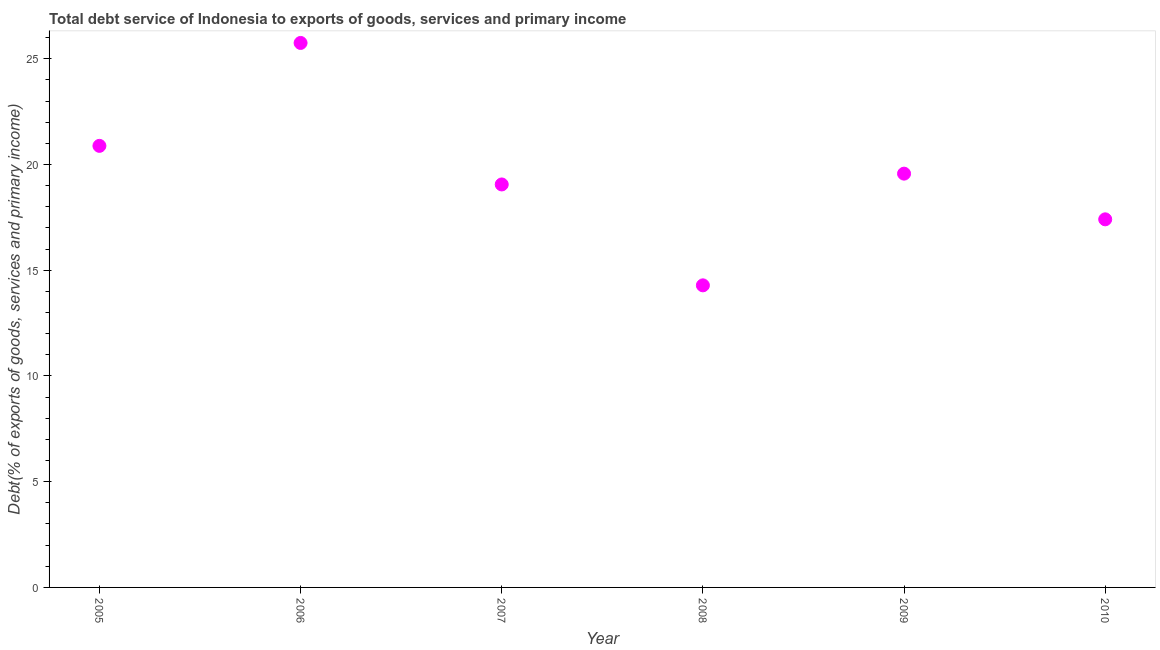What is the total debt service in 2010?
Offer a very short reply. 17.41. Across all years, what is the maximum total debt service?
Your response must be concise. 25.75. Across all years, what is the minimum total debt service?
Your answer should be compact. 14.29. What is the sum of the total debt service?
Your answer should be compact. 116.94. What is the difference between the total debt service in 2006 and 2009?
Offer a very short reply. 6.18. What is the average total debt service per year?
Make the answer very short. 19.49. What is the median total debt service?
Ensure brevity in your answer.  19.31. What is the ratio of the total debt service in 2005 to that in 2009?
Your answer should be very brief. 1.07. Is the total debt service in 2007 less than that in 2008?
Provide a succinct answer. No. What is the difference between the highest and the second highest total debt service?
Keep it short and to the point. 4.87. What is the difference between the highest and the lowest total debt service?
Offer a terse response. 11.46. Does the total debt service monotonically increase over the years?
Offer a very short reply. No. How many years are there in the graph?
Your answer should be compact. 6. Are the values on the major ticks of Y-axis written in scientific E-notation?
Offer a terse response. No. What is the title of the graph?
Make the answer very short. Total debt service of Indonesia to exports of goods, services and primary income. What is the label or title of the X-axis?
Offer a very short reply. Year. What is the label or title of the Y-axis?
Your response must be concise. Debt(% of exports of goods, services and primary income). What is the Debt(% of exports of goods, services and primary income) in 2005?
Provide a short and direct response. 20.88. What is the Debt(% of exports of goods, services and primary income) in 2006?
Keep it short and to the point. 25.75. What is the Debt(% of exports of goods, services and primary income) in 2007?
Keep it short and to the point. 19.06. What is the Debt(% of exports of goods, services and primary income) in 2008?
Offer a terse response. 14.29. What is the Debt(% of exports of goods, services and primary income) in 2009?
Your response must be concise. 19.57. What is the Debt(% of exports of goods, services and primary income) in 2010?
Provide a succinct answer. 17.41. What is the difference between the Debt(% of exports of goods, services and primary income) in 2005 and 2006?
Your answer should be compact. -4.87. What is the difference between the Debt(% of exports of goods, services and primary income) in 2005 and 2007?
Offer a terse response. 1.82. What is the difference between the Debt(% of exports of goods, services and primary income) in 2005 and 2008?
Your answer should be very brief. 6.6. What is the difference between the Debt(% of exports of goods, services and primary income) in 2005 and 2009?
Ensure brevity in your answer.  1.31. What is the difference between the Debt(% of exports of goods, services and primary income) in 2005 and 2010?
Give a very brief answer. 3.47. What is the difference between the Debt(% of exports of goods, services and primary income) in 2006 and 2007?
Your response must be concise. 6.69. What is the difference between the Debt(% of exports of goods, services and primary income) in 2006 and 2008?
Offer a terse response. 11.46. What is the difference between the Debt(% of exports of goods, services and primary income) in 2006 and 2009?
Make the answer very short. 6.18. What is the difference between the Debt(% of exports of goods, services and primary income) in 2006 and 2010?
Give a very brief answer. 8.34. What is the difference between the Debt(% of exports of goods, services and primary income) in 2007 and 2008?
Offer a very short reply. 4.77. What is the difference between the Debt(% of exports of goods, services and primary income) in 2007 and 2009?
Offer a terse response. -0.51. What is the difference between the Debt(% of exports of goods, services and primary income) in 2007 and 2010?
Keep it short and to the point. 1.65. What is the difference between the Debt(% of exports of goods, services and primary income) in 2008 and 2009?
Keep it short and to the point. -5.28. What is the difference between the Debt(% of exports of goods, services and primary income) in 2008 and 2010?
Offer a terse response. -3.12. What is the difference between the Debt(% of exports of goods, services and primary income) in 2009 and 2010?
Your answer should be compact. 2.16. What is the ratio of the Debt(% of exports of goods, services and primary income) in 2005 to that in 2006?
Provide a succinct answer. 0.81. What is the ratio of the Debt(% of exports of goods, services and primary income) in 2005 to that in 2007?
Ensure brevity in your answer.  1.1. What is the ratio of the Debt(% of exports of goods, services and primary income) in 2005 to that in 2008?
Your response must be concise. 1.46. What is the ratio of the Debt(% of exports of goods, services and primary income) in 2005 to that in 2009?
Provide a succinct answer. 1.07. What is the ratio of the Debt(% of exports of goods, services and primary income) in 2005 to that in 2010?
Make the answer very short. 1.2. What is the ratio of the Debt(% of exports of goods, services and primary income) in 2006 to that in 2007?
Provide a short and direct response. 1.35. What is the ratio of the Debt(% of exports of goods, services and primary income) in 2006 to that in 2008?
Your answer should be compact. 1.8. What is the ratio of the Debt(% of exports of goods, services and primary income) in 2006 to that in 2009?
Your answer should be very brief. 1.32. What is the ratio of the Debt(% of exports of goods, services and primary income) in 2006 to that in 2010?
Your answer should be compact. 1.48. What is the ratio of the Debt(% of exports of goods, services and primary income) in 2007 to that in 2008?
Offer a terse response. 1.33. What is the ratio of the Debt(% of exports of goods, services and primary income) in 2007 to that in 2009?
Give a very brief answer. 0.97. What is the ratio of the Debt(% of exports of goods, services and primary income) in 2007 to that in 2010?
Your answer should be very brief. 1.09. What is the ratio of the Debt(% of exports of goods, services and primary income) in 2008 to that in 2009?
Your answer should be compact. 0.73. What is the ratio of the Debt(% of exports of goods, services and primary income) in 2008 to that in 2010?
Make the answer very short. 0.82. What is the ratio of the Debt(% of exports of goods, services and primary income) in 2009 to that in 2010?
Provide a succinct answer. 1.12. 